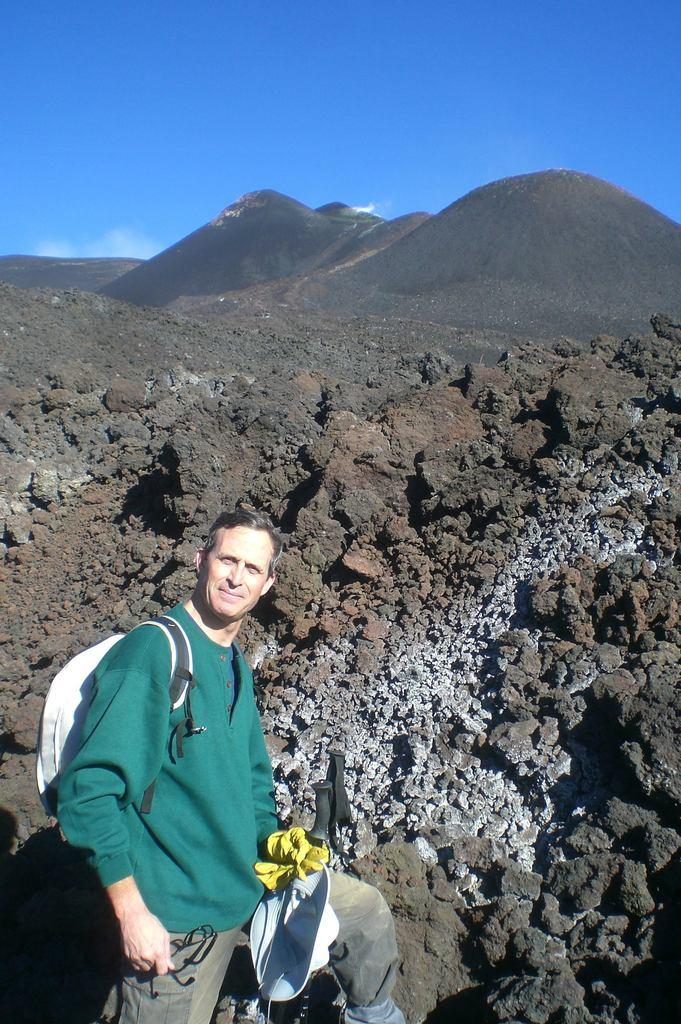What is the man in the image doing? The man is standing and carrying a bag. What is the man's facial expression in the image? The man is smiling in the image. What can be seen in the background of the image? There are rocks, mountains, and the sky visible in the background of the image. What is the condition of the sky in the image? The sky is visible, and clouds are present in the image. What is the man's voice like in the image? There is no sound or voice in the image, as it is a still photograph. What type of wave can be seen crashing on the shore in the image? There is no shore or wave present in the image; it features a man standing with a bag, rocks, mountains, and a sky with clouds. 